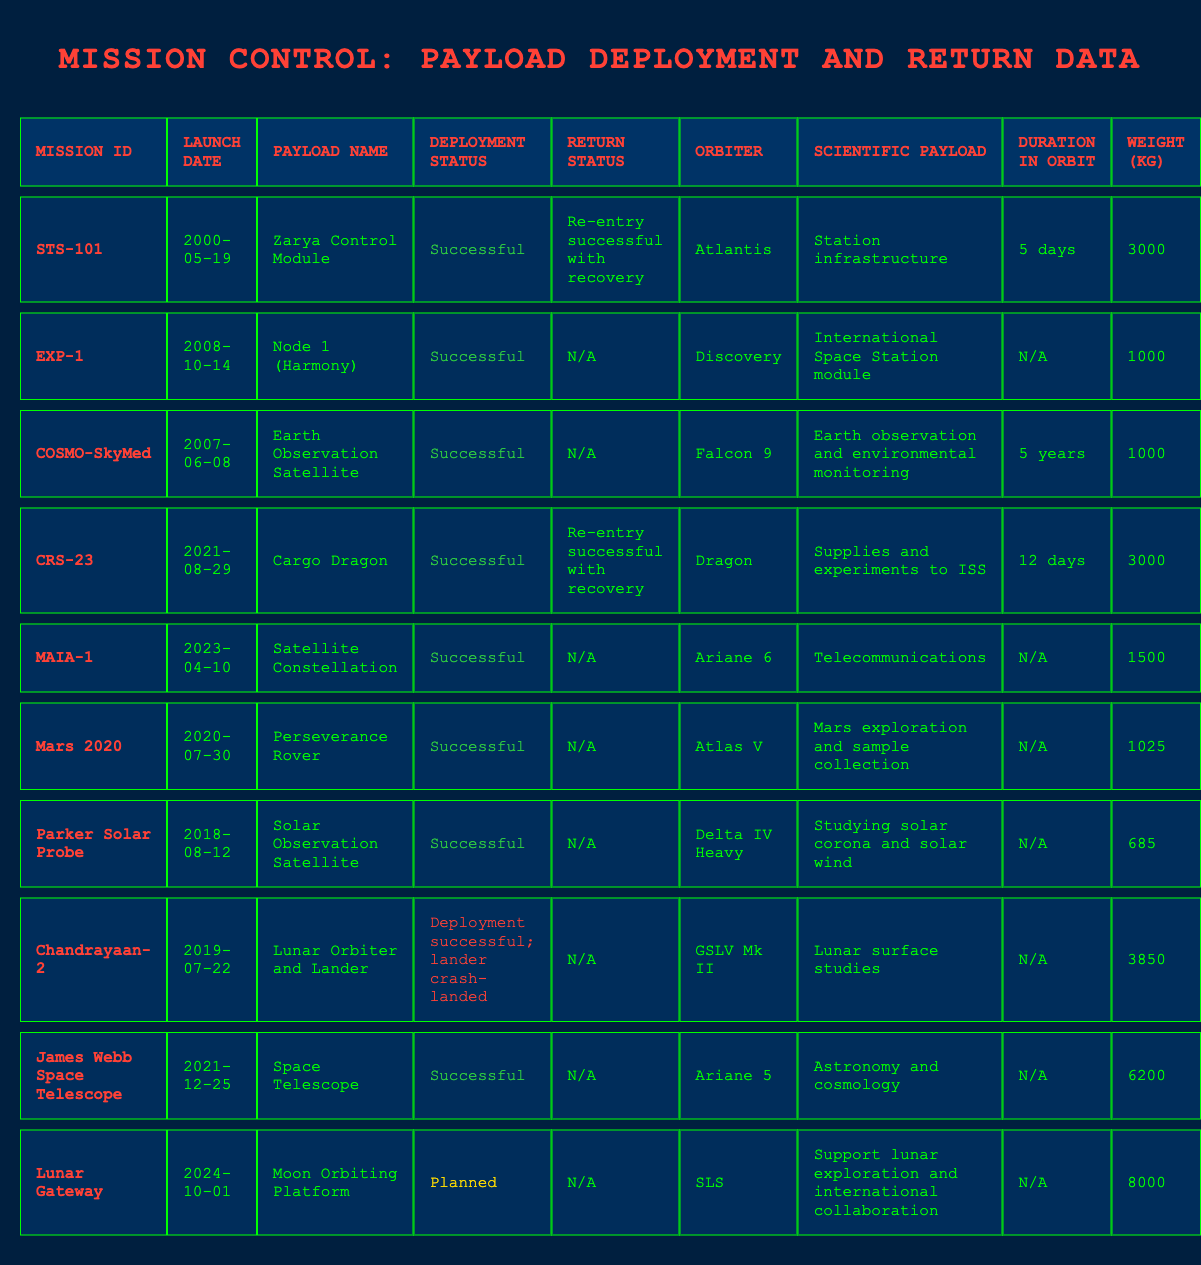What mission had the heaviest payload? The mission data shows that "Lunar Gateway" had a payload weight of 8000 kg, which is greater than all other missions listed. Other missions like "James Webb Space Telescope" had a weight of 6200 kg, and the next closest is "Chandrayaan-2" at 3850 kg. Thus, "Lunar Gateway" had the heaviest payload.
Answer: Lunar Gateway How many missions had a "Successful" deployment status? Looking through the table, we can count the missions with a "Successful" deployment status. These missions are STS-101, EXP-1, COSMO-SkyMed, CRS-23, MAIA-1, Mars 2020, Parker Solar Probe, and James Webb Space Telescope. In total, there are 8 missions with "Successful" deployment status.
Answer: 8 What is the average weight of all payloads that had a return status? To find the average weight of payloads with a return status, we need to consider the payload weights of "STS-101" (3000 kg) and "CRS-23" (3000 kg), both of which had return statuses. The total weight for these missions is 3000 + 3000 = 6000 kg, and there are 2 missions. Therefore, the average weight is 6000 / 2 = 3000 kg.
Answer: 3000 kg Did the "Chandrayaan-2" mission have a successful return? The deployment status of "Chandrayaan-2" indicates "Deployment successful; lander crash-landed," which implies that while it was deployed successfully, it did not have a successful return as there is no recorded return status.
Answer: No Which payload has the longest duration in orbit? The payload with the longest duration in orbit, according to the table, is "COSMO-SkyMed," which remained in orbit for 5 years. Other missions either have shorter durations or have 'N/A' listed. Thus, "COSMO-SkyMed" has the longest duration.
Answer: COSMO-SkyMed What is the deployment status of the "James Webb Space Telescope"? Referring to the table, the deployment status of the "James Webb Space Telescope" is "Successful," indicating that the payload was successfully deployed into orbit.
Answer: Successful How many missions planned for future launch have a weight greater than 7000 kg? The only mission listed under planned is "Lunar Gateway," which has a weight of 8000 kg. Since it is the only mission in this category, the count is 1.
Answer: 1 What was the scientific payload for the "Mars 2020" mission? According to the data in the table, the scientific payload of the "Mars 2020" mission was "Mars exploration and sample collection." This refers to the primary scientific goals.
Answer: Mars exploration and sample collection 